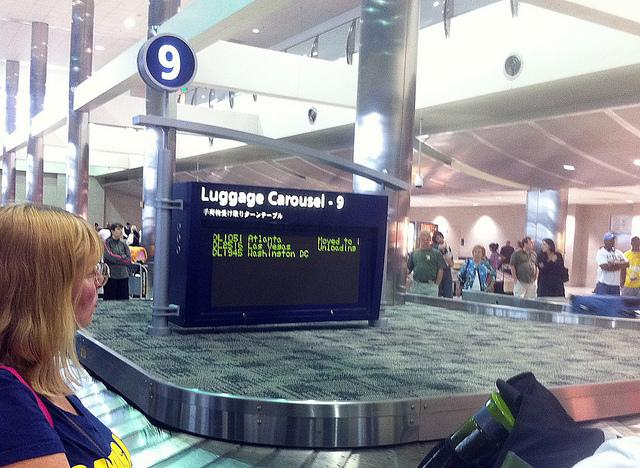What country's cities are listed on the information board? Please explain your reasoning. united states. The cities are in the us. 